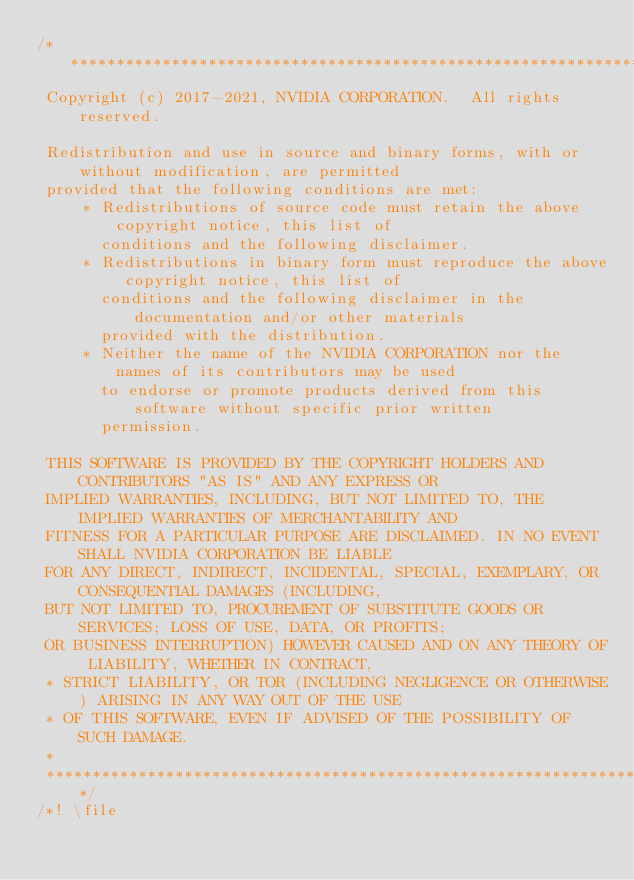Convert code to text. <code><loc_0><loc_0><loc_500><loc_500><_Cuda_>/**************************************************************************************************
 Copyright (c) 2017-2021, NVIDIA CORPORATION.  All rights reserved.

 Redistribution and use in source and binary forms, with or without modification, are permitted
 provided that the following conditions are met:
     * Redistributions of source code must retain the above copyright notice, this list of
       conditions and the following disclaimer.
     * Redistributions in binary form must reproduce the above copyright notice, this list of
       conditions and the following disclaimer in the documentation and/or other materials
       provided with the distribution.
     * Neither the name of the NVIDIA CORPORATION nor the names of its contributors may be used
       to endorse or promote products derived from this software without specific prior written
       permission.

 THIS SOFTWARE IS PROVIDED BY THE COPYRIGHT HOLDERS AND CONTRIBUTORS "AS IS" AND ANY EXPRESS OR
 IMPLIED WARRANTIES, INCLUDING, BUT NOT LIMITED TO, THE IMPLIED WARRANTIES OF MERCHANTABILITY AND
 FITNESS FOR A PARTICULAR PURPOSE ARE DISCLAIMED. IN NO EVENT SHALL NVIDIA CORPORATION BE LIABLE
 FOR ANY DIRECT, INDIRECT, INCIDENTAL, SPECIAL, EXEMPLARY, OR CONSEQUENTIAL DAMAGES (INCLUDING,
 BUT NOT LIMITED TO, PROCUREMENT OF SUBSTITUTE GOODS OR SERVICES; LOSS OF USE, DATA, OR PROFITS;
 OR BUSINESS INTERRUPTION) HOWEVER CAUSED AND ON ANY THEORY OF LIABILITY, WHETHER IN CONTRACT,
 * STRICT LIABILITY, OR TOR (INCLUDING NEGLIGENCE OR OTHERWISE) ARISING IN ANY WAY OUT OF THE USE
 * OF THIS SOFTWARE, EVEN IF ADVISED OF THE POSSIBILITY OF SUCH DAMAGE.
 *
 **************************************************************************************************/
/*! \file</code> 